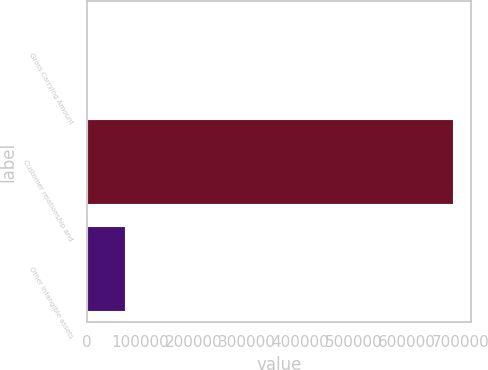<chart> <loc_0><loc_0><loc_500><loc_500><bar_chart><fcel>Gross Carrying Amount<fcel>Customer relationship and<fcel>Other intangible assets<nl><fcel>2012<fcel>685898<fcel>70400.6<nl></chart> 